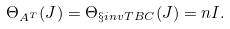Convert formula to latex. <formula><loc_0><loc_0><loc_500><loc_500>\Theta _ { A ^ { T } } ( J ) = \Theta _ { \S i n v T { B } C } ( J ) = n I .</formula> 